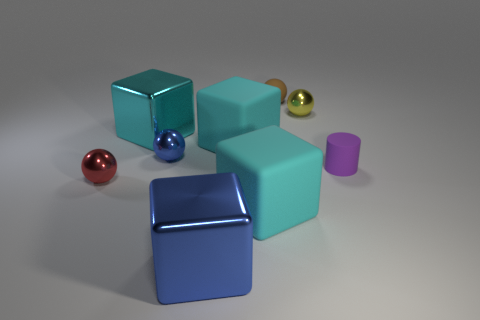How big is the matte object that is behind the small cylinder and in front of the yellow shiny thing?
Your answer should be very brief. Large. There is a brown rubber thing; is its shape the same as the small red shiny object that is in front of the tiny blue metal ball?
Ensure brevity in your answer.  Yes. There is another metallic object that is the same shape as the big blue thing; what is its size?
Offer a terse response. Large. What number of other things are there of the same size as the matte ball?
Your answer should be very brief. 4. There is a blue thing that is behind the matte thing that is to the right of the ball right of the small brown ball; what shape is it?
Ensure brevity in your answer.  Sphere. Is the size of the brown thing the same as the metallic ball on the right side of the large blue object?
Offer a terse response. Yes. The tiny thing that is both behind the cylinder and to the left of the tiny brown sphere is what color?
Offer a terse response. Blue. How many other objects are the same shape as the tiny yellow shiny thing?
Provide a succinct answer. 3. There is a large rubber cube in front of the tiny purple cylinder; is its color the same as the shiny cube behind the blue block?
Ensure brevity in your answer.  Yes. There is a yellow shiny object that is right of the brown object; is its size the same as the rubber block that is in front of the red sphere?
Provide a succinct answer. No. 